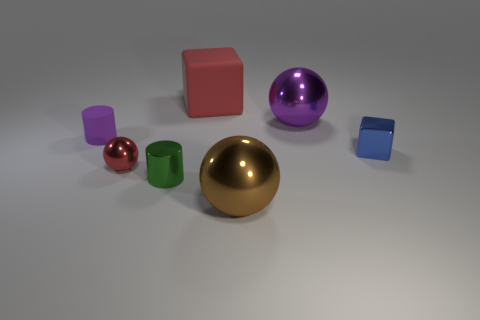Subtract all tiny red shiny balls. How many balls are left? 2 Add 1 large red rubber cubes. How many objects exist? 8 Subtract all brown spheres. How many spheres are left? 2 Subtract all cylinders. How many objects are left? 5 Add 7 small blue cubes. How many small blue cubes are left? 8 Add 7 large purple rubber things. How many large purple rubber things exist? 7 Subtract 1 red spheres. How many objects are left? 6 Subtract all blue balls. Subtract all cyan cylinders. How many balls are left? 3 Subtract all big red rubber cubes. Subtract all tiny purple matte cylinders. How many objects are left? 5 